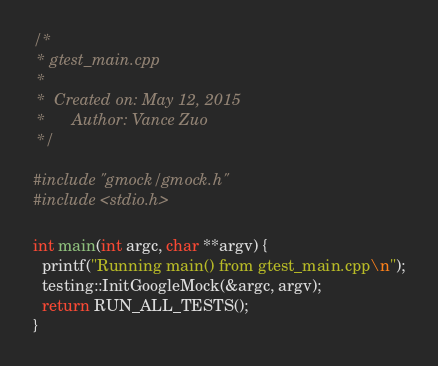Convert code to text. <code><loc_0><loc_0><loc_500><loc_500><_C++_>/*
 * gtest_main.cpp
 *
 *  Created on: May 12, 2015
 *      Author: Vance Zuo
 */

#include "gmock/gmock.h"
#include <stdio.h>

int main(int argc, char **argv) {
  printf("Running main() from gtest_main.cpp\n");
  testing::InitGoogleMock(&argc, argv);
  return RUN_ALL_TESTS();
}

</code> 